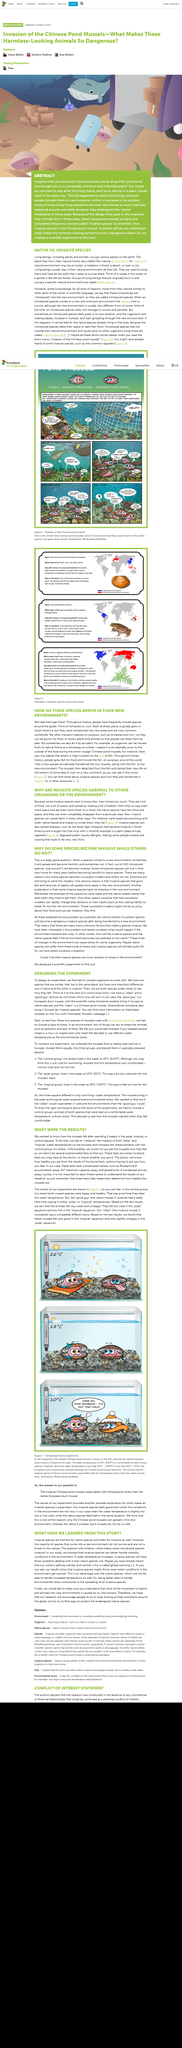List a handful of essential elements in this visual. The mussels were collected from a nearby lake. The invasive mussel S. woodiana felt slightly unhappy in the polar aquarium, as it is a fact. The Chinese pond mussel feels fine despite the 10°C temperature. The control group lived at a temperature of 18 degrees Celsius. Invasive species and native species are not the same thing. Native species are distinct from invasive species in their characteristics, behavior, and impact on ecosystems. 